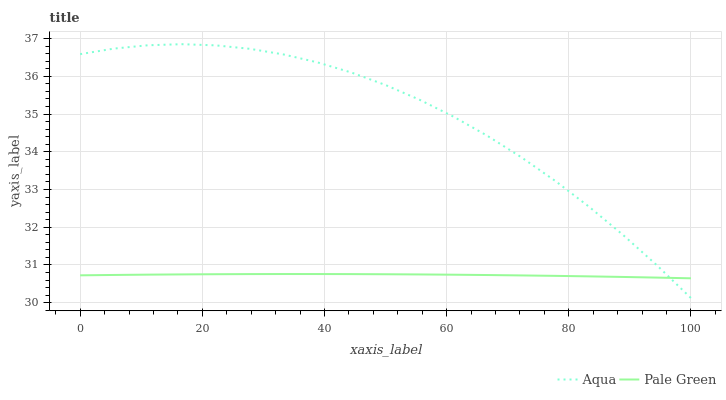Does Pale Green have the minimum area under the curve?
Answer yes or no. Yes. Does Aqua have the maximum area under the curve?
Answer yes or no. Yes. Does Aqua have the minimum area under the curve?
Answer yes or no. No. Is Pale Green the smoothest?
Answer yes or no. Yes. Is Aqua the roughest?
Answer yes or no. Yes. Is Aqua the smoothest?
Answer yes or no. No. Does Aqua have the lowest value?
Answer yes or no. Yes. Does Aqua have the highest value?
Answer yes or no. Yes. Does Aqua intersect Pale Green?
Answer yes or no. Yes. Is Aqua less than Pale Green?
Answer yes or no. No. Is Aqua greater than Pale Green?
Answer yes or no. No. 